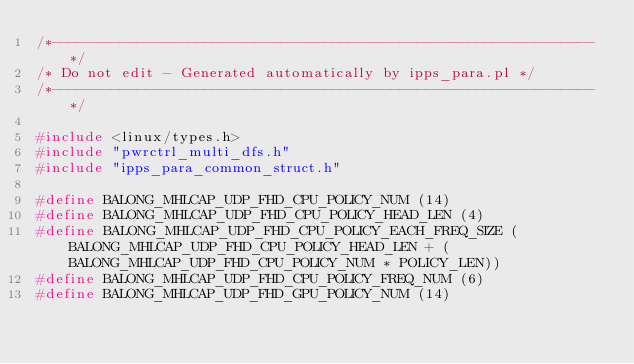Convert code to text. <code><loc_0><loc_0><loc_500><loc_500><_C_>/*----------------------------------------------------------------*/
/* Do not edit - Generated automatically by ipps_para.pl */
/*----------------------------------------------------------------*/

#include <linux/types.h>
#include "pwrctrl_multi_dfs.h"
#include "ipps_para_common_struct.h"

#define BALONG_MHLCAP_UDP_FHD_CPU_POLICY_NUM (14)
#define BALONG_MHLCAP_UDP_FHD_CPU_POLICY_HEAD_LEN (4)
#define BALONG_MHLCAP_UDP_FHD_CPU_POLICY_EACH_FREQ_SIZE (BALONG_MHLCAP_UDP_FHD_CPU_POLICY_HEAD_LEN + (BALONG_MHLCAP_UDP_FHD_CPU_POLICY_NUM * POLICY_LEN))
#define BALONG_MHLCAP_UDP_FHD_CPU_POLICY_FREQ_NUM (6)
#define BALONG_MHLCAP_UDP_FHD_GPU_POLICY_NUM (14)</code> 